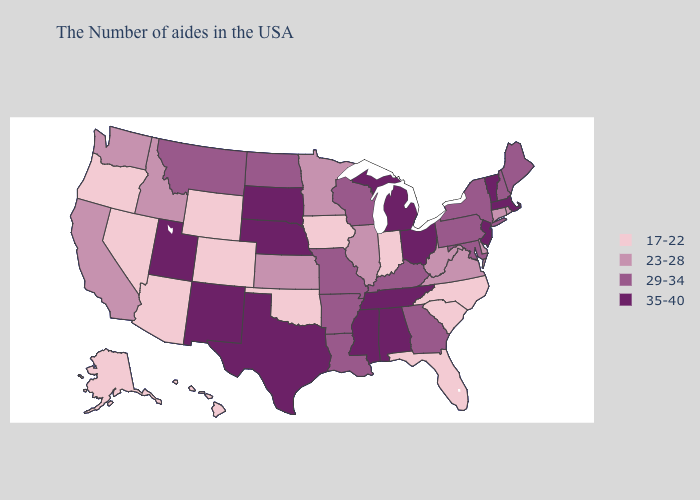Does New Mexico have the lowest value in the USA?
Write a very short answer. No. Which states have the highest value in the USA?
Answer briefly. Massachusetts, Vermont, New Jersey, Ohio, Michigan, Alabama, Tennessee, Mississippi, Nebraska, Texas, South Dakota, New Mexico, Utah. What is the highest value in states that border Nevada?
Answer briefly. 35-40. Does North Dakota have the lowest value in the MidWest?
Concise answer only. No. What is the value of New York?
Write a very short answer. 29-34. Name the states that have a value in the range 35-40?
Short answer required. Massachusetts, Vermont, New Jersey, Ohio, Michigan, Alabama, Tennessee, Mississippi, Nebraska, Texas, South Dakota, New Mexico, Utah. What is the value of Louisiana?
Answer briefly. 29-34. Name the states that have a value in the range 35-40?
Keep it brief. Massachusetts, Vermont, New Jersey, Ohio, Michigan, Alabama, Tennessee, Mississippi, Nebraska, Texas, South Dakota, New Mexico, Utah. Name the states that have a value in the range 29-34?
Give a very brief answer. Maine, New Hampshire, New York, Maryland, Pennsylvania, Georgia, Kentucky, Wisconsin, Louisiana, Missouri, Arkansas, North Dakota, Montana. Which states have the highest value in the USA?
Be succinct. Massachusetts, Vermont, New Jersey, Ohio, Michigan, Alabama, Tennessee, Mississippi, Nebraska, Texas, South Dakota, New Mexico, Utah. Does Nevada have a lower value than Louisiana?
Short answer required. Yes. Does Louisiana have a lower value than Kentucky?
Quick response, please. No. Which states have the highest value in the USA?
Give a very brief answer. Massachusetts, Vermont, New Jersey, Ohio, Michigan, Alabama, Tennessee, Mississippi, Nebraska, Texas, South Dakota, New Mexico, Utah. What is the highest value in states that border Nevada?
Write a very short answer. 35-40. Name the states that have a value in the range 17-22?
Write a very short answer. North Carolina, South Carolina, Florida, Indiana, Iowa, Oklahoma, Wyoming, Colorado, Arizona, Nevada, Oregon, Alaska, Hawaii. 